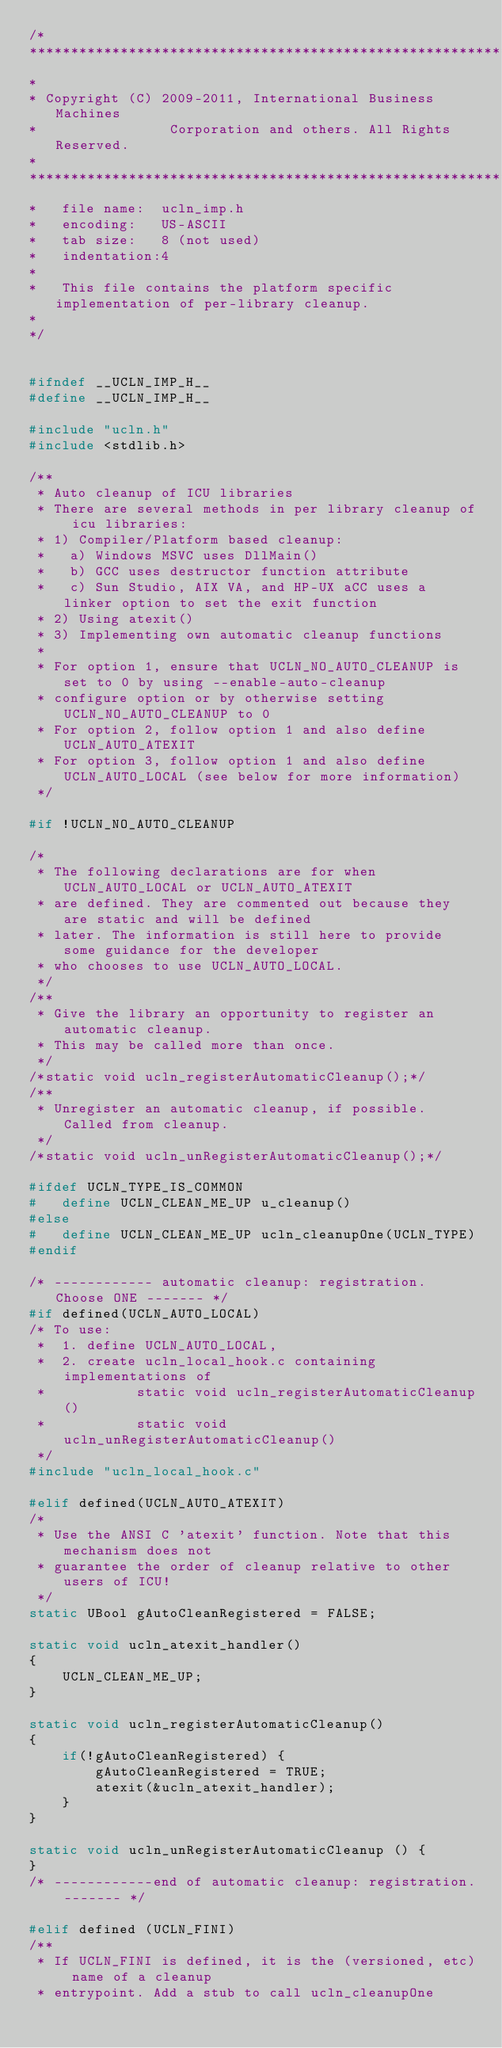Convert code to text. <code><loc_0><loc_0><loc_500><loc_500><_C_>/*
******************************************************************************
*
* Copyright (C) 2009-2011, International Business Machines
*                Corporation and others. All Rights Reserved.
*
******************************************************************************
*   file name:  ucln_imp.h
*   encoding:   US-ASCII
*   tab size:   8 (not used)
*   indentation:4
*
*   This file contains the platform specific implementation of per-library cleanup.
*
*/


#ifndef __UCLN_IMP_H__
#define __UCLN_IMP_H__

#include "ucln.h"
#include <stdlib.h>

/**
 * Auto cleanup of ICU libraries
 * There are several methods in per library cleanup of icu libraries:
 * 1) Compiler/Platform based cleanup:
 *   a) Windows MSVC uses DllMain()
 *   b) GCC uses destructor function attribute
 *   c) Sun Studio, AIX VA, and HP-UX aCC uses a linker option to set the exit function
 * 2) Using atexit()
 * 3) Implementing own automatic cleanup functions
 *
 * For option 1, ensure that UCLN_NO_AUTO_CLEANUP is set to 0 by using --enable-auto-cleanup
 * configure option or by otherwise setting UCLN_NO_AUTO_CLEANUP to 0
 * For option 2, follow option 1 and also define UCLN_AUTO_ATEXIT
 * For option 3, follow option 1 and also define UCLN_AUTO_LOCAL (see below for more information)
 */

#if !UCLN_NO_AUTO_CLEANUP

/*
 * The following declarations are for when UCLN_AUTO_LOCAL or UCLN_AUTO_ATEXIT
 * are defined. They are commented out because they are static and will be defined
 * later. The information is still here to provide some guidance for the developer
 * who chooses to use UCLN_AUTO_LOCAL.
 */
/**
 * Give the library an opportunity to register an automatic cleanup.
 * This may be called more than once.
 */
/*static void ucln_registerAutomaticCleanup();*/
/**
 * Unregister an automatic cleanup, if possible. Called from cleanup.
 */
/*static void ucln_unRegisterAutomaticCleanup();*/

#ifdef UCLN_TYPE_IS_COMMON
#   define UCLN_CLEAN_ME_UP u_cleanup()
#else
#   define UCLN_CLEAN_ME_UP ucln_cleanupOne(UCLN_TYPE)
#endif

/* ------------ automatic cleanup: registration. Choose ONE ------- */
#if defined(UCLN_AUTO_LOCAL)
/* To use:
 *  1. define UCLN_AUTO_LOCAL,
 *  2. create ucln_local_hook.c containing implementations of
 *           static void ucln_registerAutomaticCleanup()
 *           static void ucln_unRegisterAutomaticCleanup()
 */
#include "ucln_local_hook.c"

#elif defined(UCLN_AUTO_ATEXIT)
/*
 * Use the ANSI C 'atexit' function. Note that this mechanism does not
 * guarantee the order of cleanup relative to other users of ICU!
 */
static UBool gAutoCleanRegistered = FALSE;

static void ucln_atexit_handler()
{
    UCLN_CLEAN_ME_UP;
}

static void ucln_registerAutomaticCleanup()
{
    if(!gAutoCleanRegistered) {
        gAutoCleanRegistered = TRUE;
        atexit(&ucln_atexit_handler);
    }
}

static void ucln_unRegisterAutomaticCleanup () {
}
/* ------------end of automatic cleanup: registration. ------- */

#elif defined (UCLN_FINI)
/**
 * If UCLN_FINI is defined, it is the (versioned, etc) name of a cleanup
 * entrypoint. Add a stub to call ucln_cleanupOne</code> 